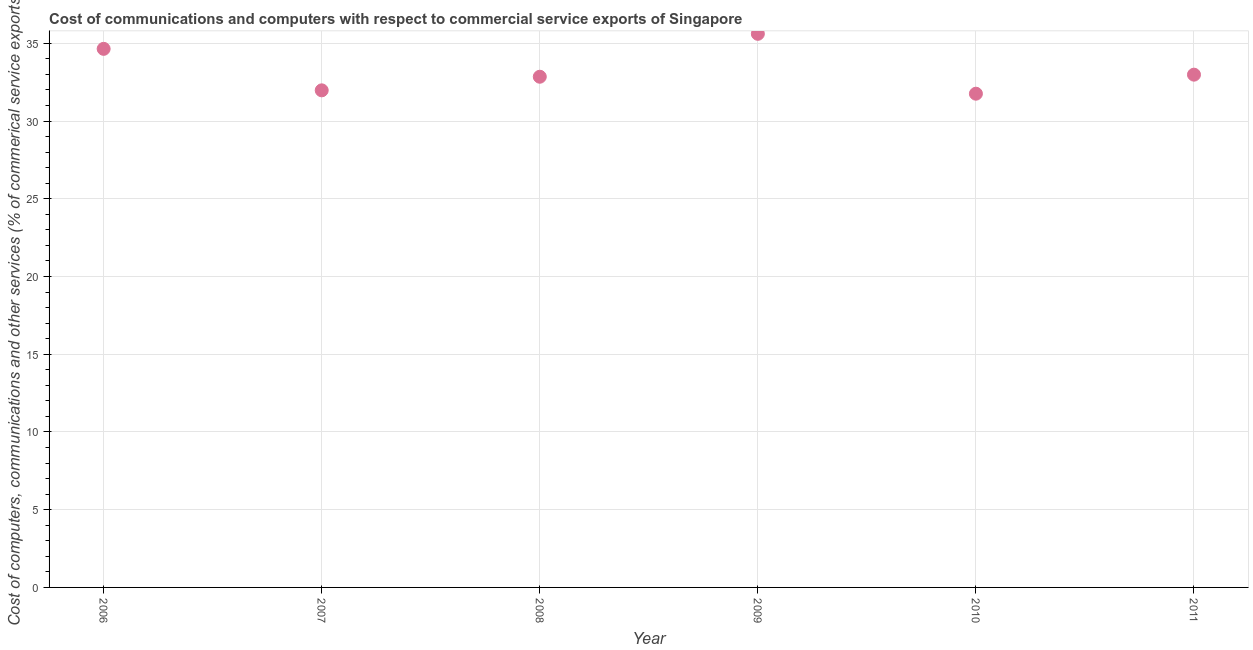What is the  computer and other services in 2008?
Your answer should be compact. 32.85. Across all years, what is the maximum  computer and other services?
Your answer should be very brief. 35.61. Across all years, what is the minimum cost of communications?
Provide a succinct answer. 31.76. In which year was the cost of communications minimum?
Your answer should be compact. 2010. What is the sum of the  computer and other services?
Your answer should be very brief. 199.82. What is the difference between the cost of communications in 2006 and 2010?
Your answer should be compact. 2.89. What is the average  computer and other services per year?
Offer a terse response. 33.3. What is the median  computer and other services?
Your answer should be very brief. 32.92. What is the ratio of the cost of communications in 2006 to that in 2010?
Provide a succinct answer. 1.09. Is the difference between the cost of communications in 2008 and 2010 greater than the difference between any two years?
Give a very brief answer. No. What is the difference between the highest and the second highest  computer and other services?
Your response must be concise. 0.97. Is the sum of the cost of communications in 2010 and 2011 greater than the maximum cost of communications across all years?
Ensure brevity in your answer.  Yes. What is the difference between the highest and the lowest  computer and other services?
Your response must be concise. 3.85. What is the title of the graph?
Offer a very short reply. Cost of communications and computers with respect to commercial service exports of Singapore. What is the label or title of the Y-axis?
Offer a terse response. Cost of computers, communications and other services (% of commerical service exports). What is the Cost of computers, communications and other services (% of commerical service exports) in 2006?
Ensure brevity in your answer.  34.64. What is the Cost of computers, communications and other services (% of commerical service exports) in 2007?
Offer a very short reply. 31.98. What is the Cost of computers, communications and other services (% of commerical service exports) in 2008?
Keep it short and to the point. 32.85. What is the Cost of computers, communications and other services (% of commerical service exports) in 2009?
Give a very brief answer. 35.61. What is the Cost of computers, communications and other services (% of commerical service exports) in 2010?
Provide a succinct answer. 31.76. What is the Cost of computers, communications and other services (% of commerical service exports) in 2011?
Your answer should be very brief. 32.98. What is the difference between the Cost of computers, communications and other services (% of commerical service exports) in 2006 and 2007?
Your answer should be compact. 2.67. What is the difference between the Cost of computers, communications and other services (% of commerical service exports) in 2006 and 2008?
Your response must be concise. 1.79. What is the difference between the Cost of computers, communications and other services (% of commerical service exports) in 2006 and 2009?
Offer a very short reply. -0.97. What is the difference between the Cost of computers, communications and other services (% of commerical service exports) in 2006 and 2010?
Keep it short and to the point. 2.89. What is the difference between the Cost of computers, communications and other services (% of commerical service exports) in 2006 and 2011?
Provide a short and direct response. 1.66. What is the difference between the Cost of computers, communications and other services (% of commerical service exports) in 2007 and 2008?
Ensure brevity in your answer.  -0.88. What is the difference between the Cost of computers, communications and other services (% of commerical service exports) in 2007 and 2009?
Ensure brevity in your answer.  -3.64. What is the difference between the Cost of computers, communications and other services (% of commerical service exports) in 2007 and 2010?
Make the answer very short. 0.22. What is the difference between the Cost of computers, communications and other services (% of commerical service exports) in 2007 and 2011?
Your response must be concise. -1.01. What is the difference between the Cost of computers, communications and other services (% of commerical service exports) in 2008 and 2009?
Your answer should be very brief. -2.76. What is the difference between the Cost of computers, communications and other services (% of commerical service exports) in 2008 and 2010?
Your response must be concise. 1.09. What is the difference between the Cost of computers, communications and other services (% of commerical service exports) in 2008 and 2011?
Make the answer very short. -0.13. What is the difference between the Cost of computers, communications and other services (% of commerical service exports) in 2009 and 2010?
Offer a terse response. 3.85. What is the difference between the Cost of computers, communications and other services (% of commerical service exports) in 2009 and 2011?
Keep it short and to the point. 2.63. What is the difference between the Cost of computers, communications and other services (% of commerical service exports) in 2010 and 2011?
Make the answer very short. -1.22. What is the ratio of the Cost of computers, communications and other services (% of commerical service exports) in 2006 to that in 2007?
Your answer should be compact. 1.08. What is the ratio of the Cost of computers, communications and other services (% of commerical service exports) in 2006 to that in 2008?
Ensure brevity in your answer.  1.05. What is the ratio of the Cost of computers, communications and other services (% of commerical service exports) in 2006 to that in 2009?
Provide a short and direct response. 0.97. What is the ratio of the Cost of computers, communications and other services (% of commerical service exports) in 2006 to that in 2010?
Keep it short and to the point. 1.09. What is the ratio of the Cost of computers, communications and other services (% of commerical service exports) in 2006 to that in 2011?
Ensure brevity in your answer.  1.05. What is the ratio of the Cost of computers, communications and other services (% of commerical service exports) in 2007 to that in 2008?
Make the answer very short. 0.97. What is the ratio of the Cost of computers, communications and other services (% of commerical service exports) in 2007 to that in 2009?
Your answer should be very brief. 0.9. What is the ratio of the Cost of computers, communications and other services (% of commerical service exports) in 2007 to that in 2010?
Your answer should be compact. 1.01. What is the ratio of the Cost of computers, communications and other services (% of commerical service exports) in 2007 to that in 2011?
Keep it short and to the point. 0.97. What is the ratio of the Cost of computers, communications and other services (% of commerical service exports) in 2008 to that in 2009?
Offer a very short reply. 0.92. What is the ratio of the Cost of computers, communications and other services (% of commerical service exports) in 2008 to that in 2010?
Make the answer very short. 1.03. What is the ratio of the Cost of computers, communications and other services (% of commerical service exports) in 2008 to that in 2011?
Make the answer very short. 1. What is the ratio of the Cost of computers, communications and other services (% of commerical service exports) in 2009 to that in 2010?
Ensure brevity in your answer.  1.12. What is the ratio of the Cost of computers, communications and other services (% of commerical service exports) in 2009 to that in 2011?
Your answer should be very brief. 1.08. What is the ratio of the Cost of computers, communications and other services (% of commerical service exports) in 2010 to that in 2011?
Your answer should be very brief. 0.96. 